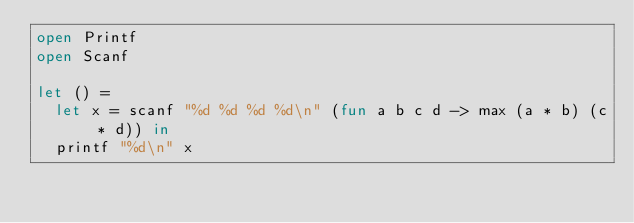<code> <loc_0><loc_0><loc_500><loc_500><_OCaml_>open Printf
open Scanf

let () =
  let x = scanf "%d %d %d %d\n" (fun a b c d -> max (a * b) (c * d)) in
  printf "%d\n" x
</code> 